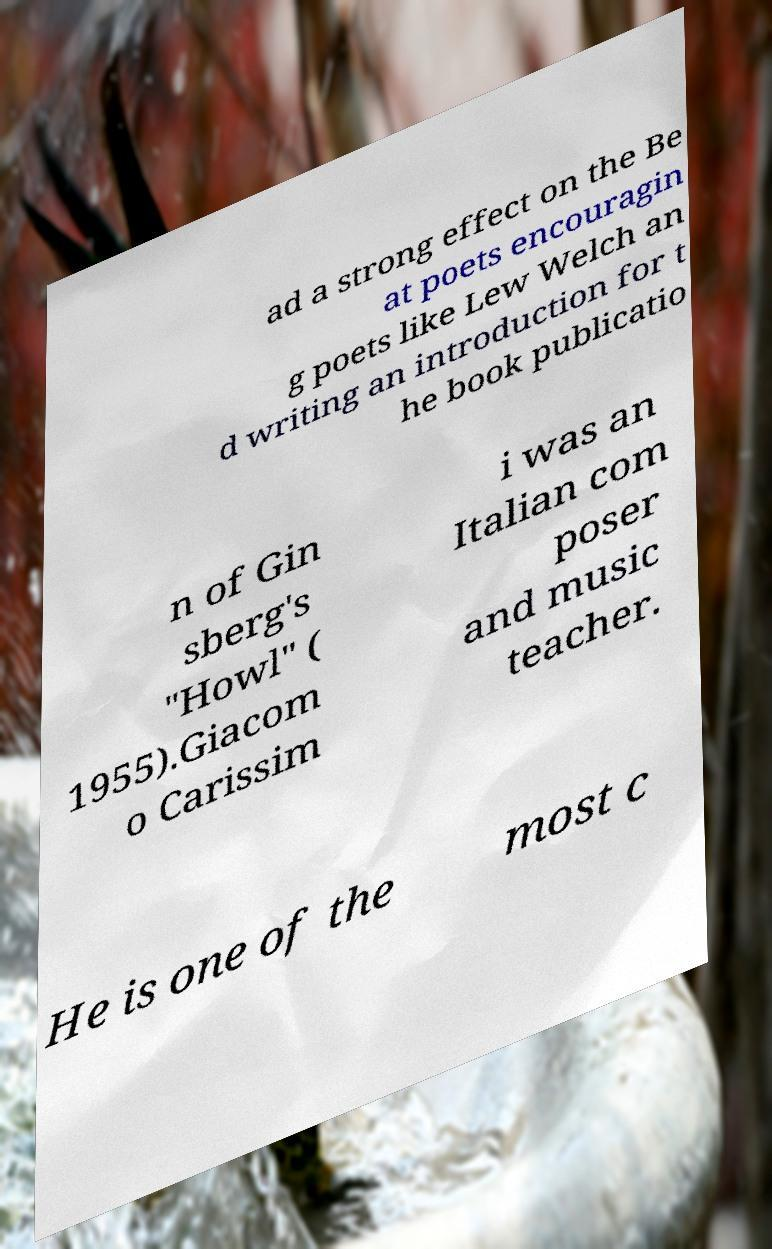Please read and relay the text visible in this image. What does it say? ad a strong effect on the Be at poets encouragin g poets like Lew Welch an d writing an introduction for t he book publicatio n of Gin sberg's "Howl" ( 1955).Giacom o Carissim i was an Italian com poser and music teacher. He is one of the most c 